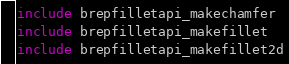<code> <loc_0><loc_0><loc_500><loc_500><_Nim_>include brepfilletapi_makechamfer
include brepfilletapi_makefillet
include brepfilletapi_makefillet2d
</code> 